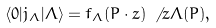<formula> <loc_0><loc_0><loc_500><loc_500>\langle 0 | j _ { \Lambda } | \Lambda \rangle = f _ { \Lambda } ( P \cdot z ) \, \not \, z \Lambda ( P ) ,</formula> 